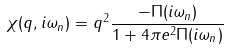<formula> <loc_0><loc_0><loc_500><loc_500>\chi ( q , i \omega _ { n } ) = q ^ { 2 } \frac { - \Pi ( i \omega _ { n } ) } { 1 + 4 \pi e ^ { 2 } \Pi ( i \omega _ { n } ) }</formula> 